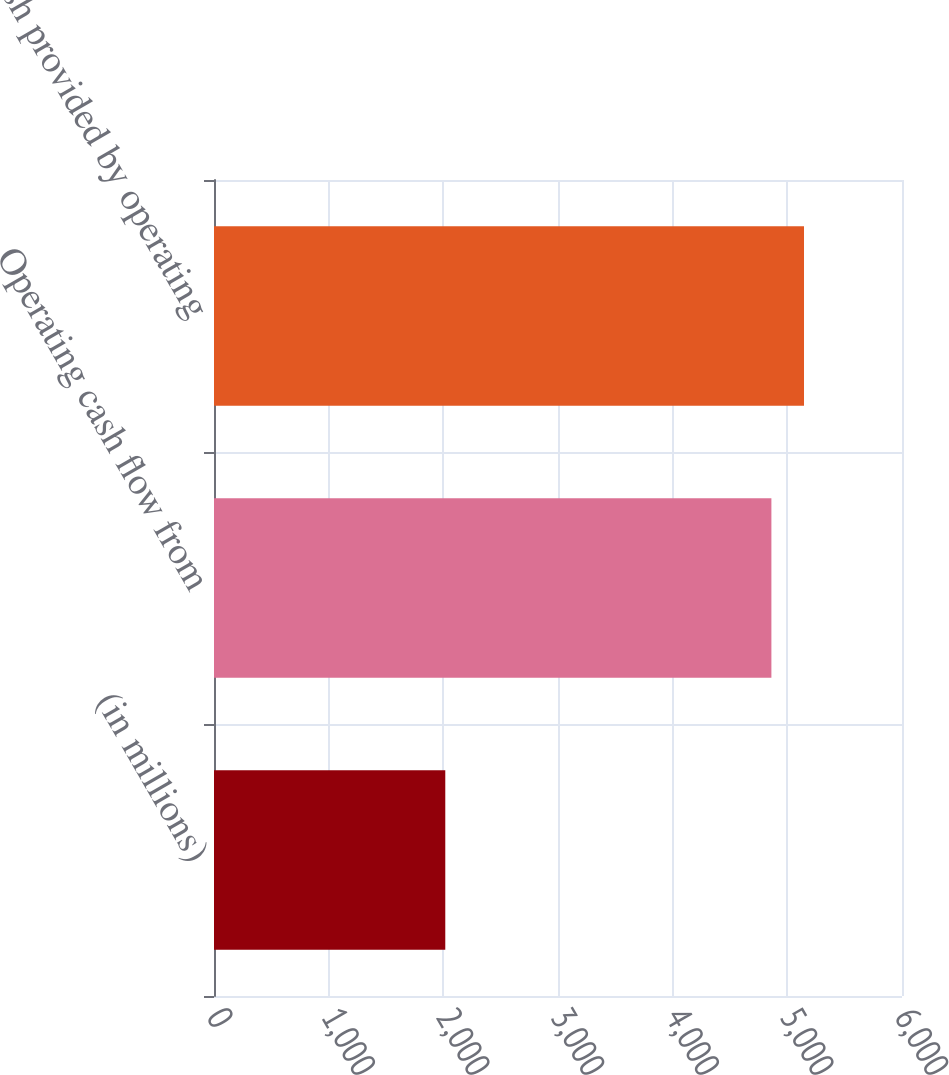Convert chart to OTSL. <chart><loc_0><loc_0><loc_500><loc_500><bar_chart><fcel>(in millions)<fcel>Operating cash flow from<fcel>Net cash provided by operating<nl><fcel>2017<fcel>4861<fcel>5145.4<nl></chart> 